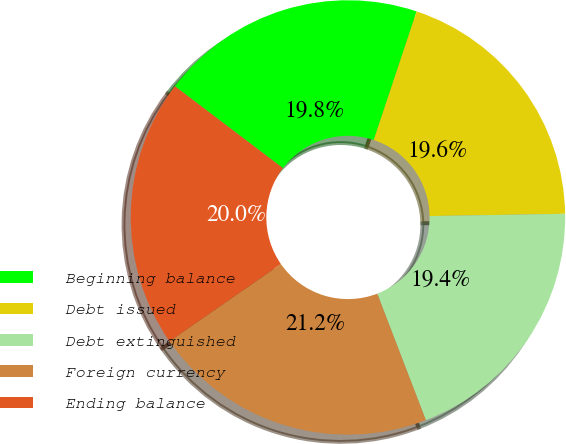Convert chart. <chart><loc_0><loc_0><loc_500><loc_500><pie_chart><fcel>Beginning balance<fcel>Debt issued<fcel>Debt extinguished<fcel>Foreign currency<fcel>Ending balance<nl><fcel>19.8%<fcel>19.61%<fcel>19.43%<fcel>21.19%<fcel>19.98%<nl></chart> 